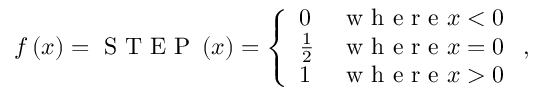<formula> <loc_0><loc_0><loc_500><loc_500>f \left ( x \right ) = S T E P \left ( x \right ) = \left \{ \begin{array} { l l } { 0 } & { w h e r e x < 0 } \\ { \frac { 1 } { 2 } } & { w h e r e x = 0 } \\ { 1 } & { w h e r e x > 0 } \end{array} ,</formula> 